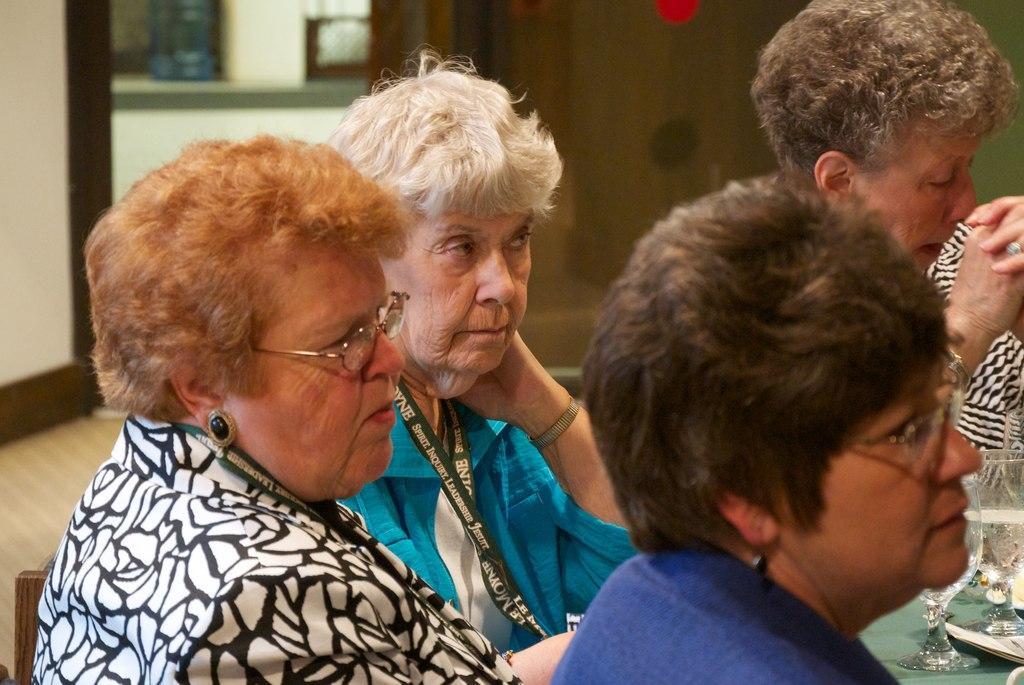Describe this image in one or two sentences. In this image I can see four women and I can see two of them are wearing ID cards. I can two of them are wearing specs. Here I can see few glasses and in it I can see drinks. I can see this image is little bit blurry from background. 